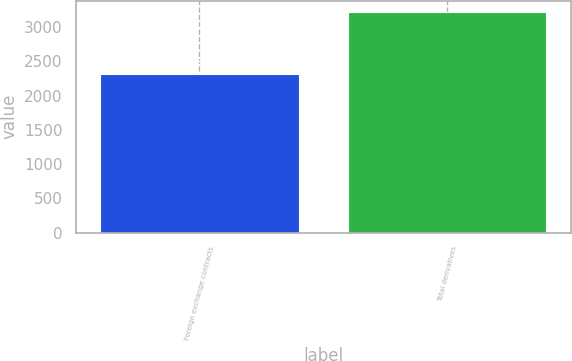Convert chart. <chart><loc_0><loc_0><loc_500><loc_500><bar_chart><fcel>Foreign exchange contracts<fcel>Total derivatives<nl><fcel>2310<fcel>3224<nl></chart> 